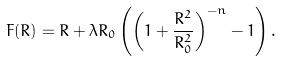<formula> <loc_0><loc_0><loc_500><loc_500>F ( R ) = R + \lambda R _ { 0 } \left ( \left ( 1 + \frac { R ^ { 2 } } { R _ { 0 } ^ { 2 } } \right ) ^ { - n } - 1 \right ) .</formula> 